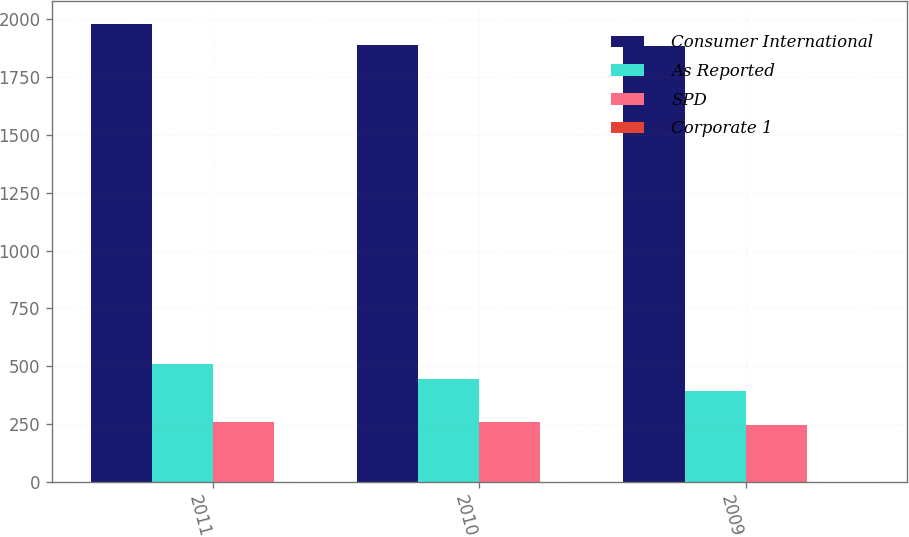<chart> <loc_0><loc_0><loc_500><loc_500><stacked_bar_chart><ecel><fcel>2011<fcel>2010<fcel>2009<nl><fcel>Consumer International<fcel>1979.1<fcel>1886.1<fcel>1881.7<nl><fcel>As Reported<fcel>509.1<fcel>444<fcel>393.7<nl><fcel>SPD<fcel>261.1<fcel>259.1<fcel>245.5<nl><fcel>Corporate 1<fcel>0<fcel>0<fcel>0<nl></chart> 